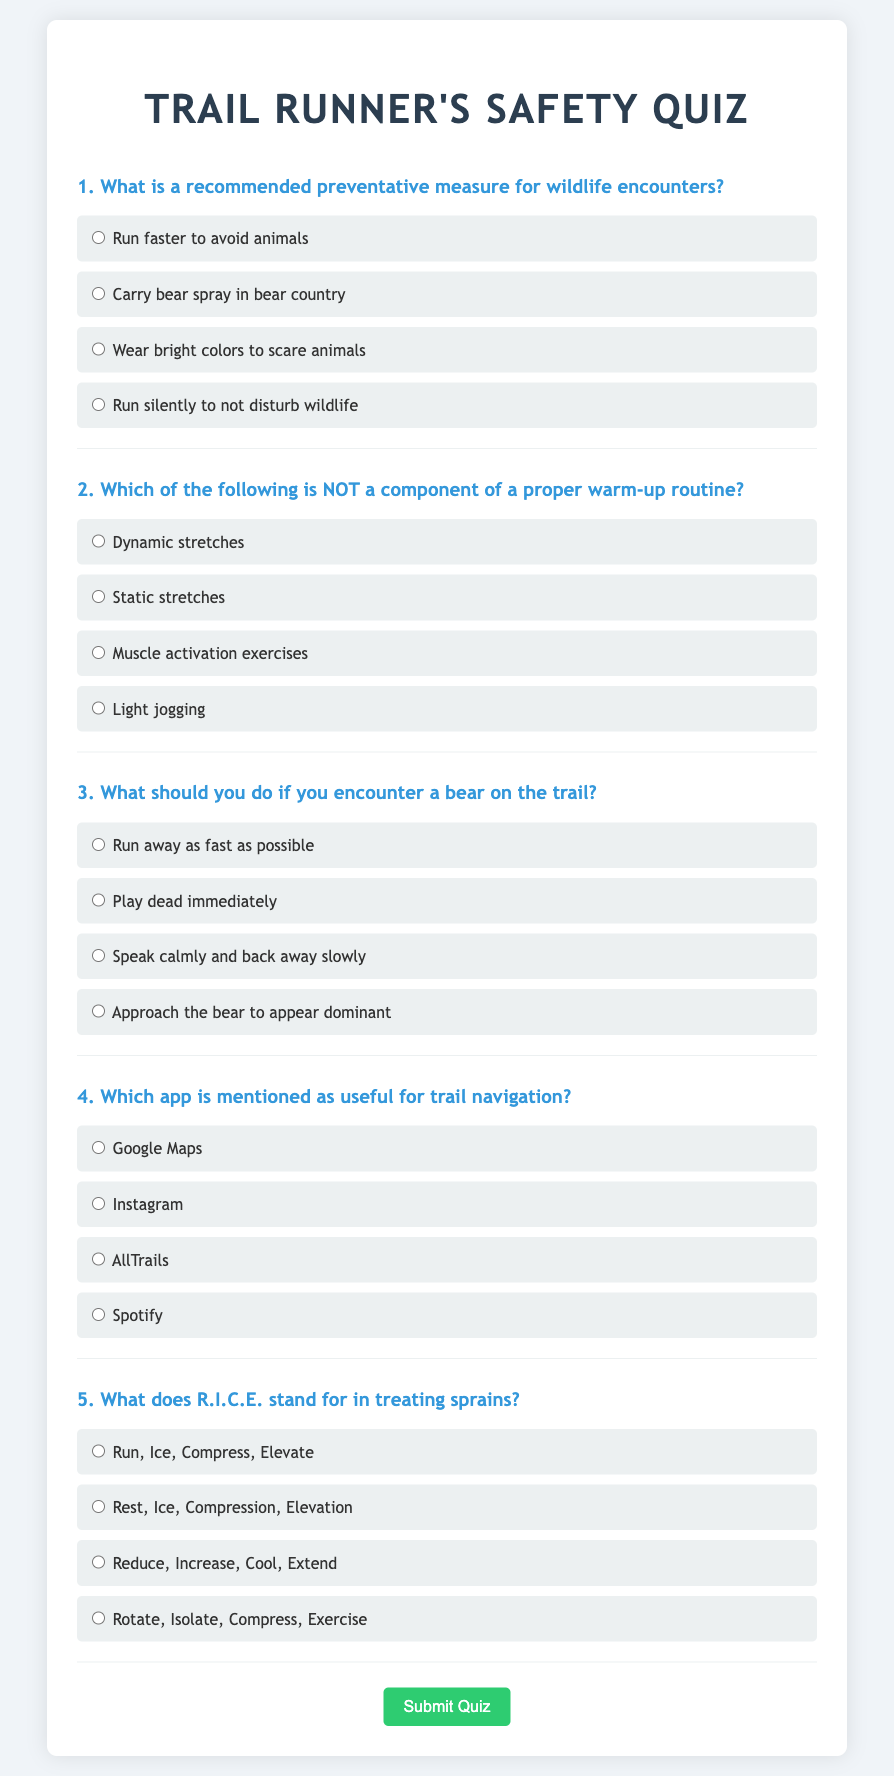what is the title of the document? The title is found in the `<title>` tag of the document, which reads "Trail Runner's Safety Quiz."
Answer: Trail Runner's Safety Quiz how many questions are in the quiz? There are five distinct questions listed in the quiz, each followed by multiple-choice answers.
Answer: 5 what does R.I.C.E. stand for in treating sprains? The acronym R.I.C.E. is explained in question 5, which outlines its meaning directly related to sprain treatment.
Answer: Rest, Ice, Compression, Elevation which app is mentioned as useful for trail navigation? The app useful for trail navigation is directly presented in question 4, where options are provided.
Answer: AllTrails what is a recommended preventative measure for wildlife encounters? This information is presented in question 1, which outlines safety practices when encountering wildlife while running.
Answer: Carry bear spray in bear country what should you do if you encounter a bear on the trail? Question 3 specifies the necessary action to take upon meeting a bear on a trail, providing safety guidelines for runners.
Answer: Speak calmly and back away slowly which option is NOT a component of a proper warm-up routine? Question 2 asks which option does not belong in a warm-up routine, helping highlight essential warm-up activities.
Answer: Static stretches 